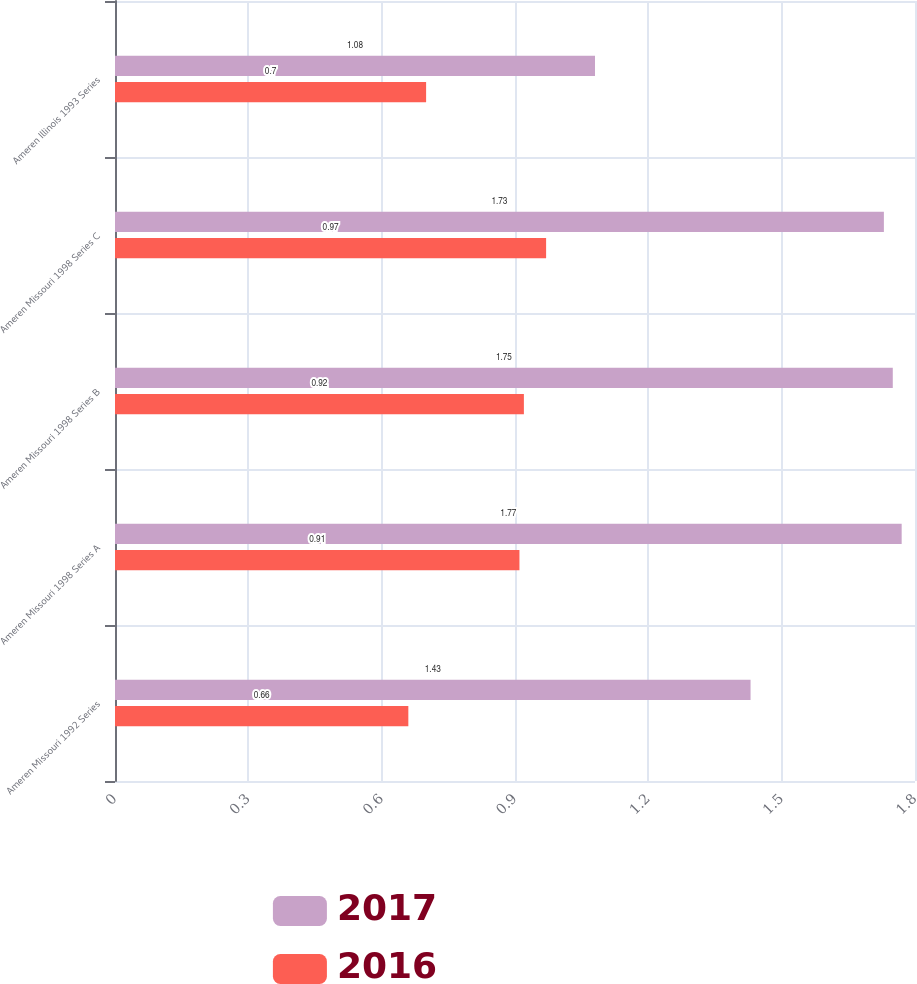<chart> <loc_0><loc_0><loc_500><loc_500><stacked_bar_chart><ecel><fcel>Ameren Missouri 1992 Series<fcel>Ameren Missouri 1998 Series A<fcel>Ameren Missouri 1998 Series B<fcel>Ameren Missouri 1998 Series C<fcel>Ameren Illinois 1993 Series<nl><fcel>2017<fcel>1.43<fcel>1.77<fcel>1.75<fcel>1.73<fcel>1.08<nl><fcel>2016<fcel>0.66<fcel>0.91<fcel>0.92<fcel>0.97<fcel>0.7<nl></chart> 